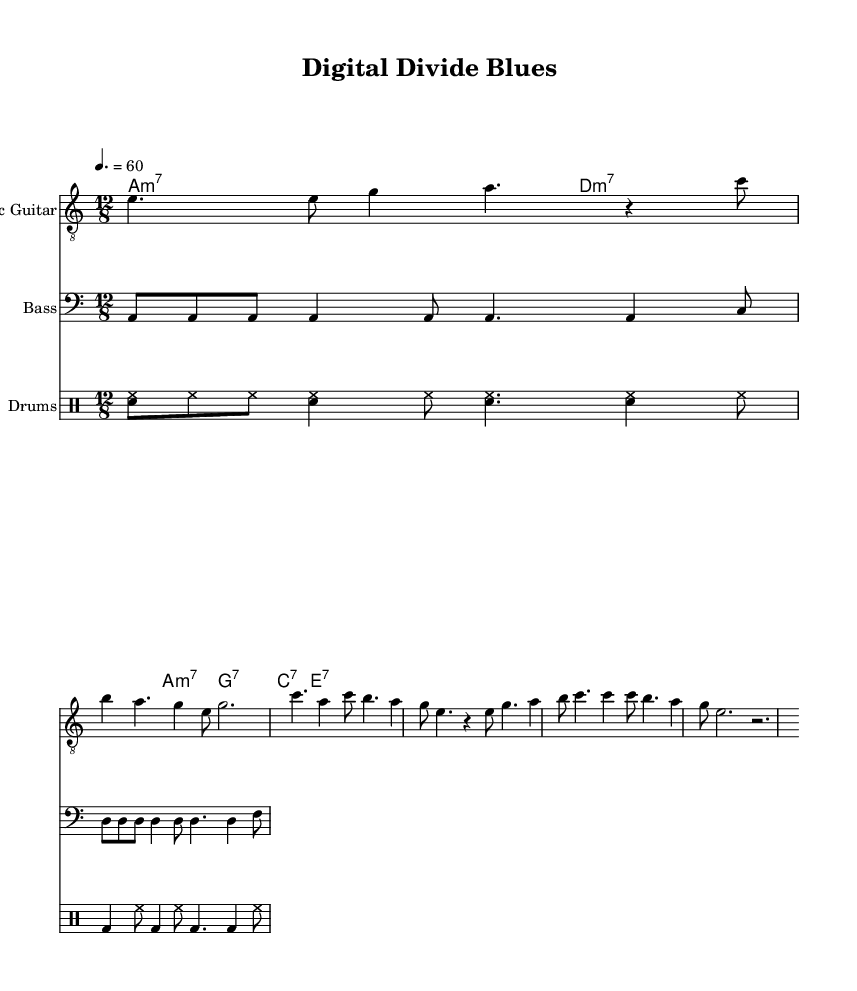What is the key signature of this music? The key signature is A minor, which has no sharps or flats.
Answer: A minor What is the time signature of this piece? The time signature is written in the top left of the sheet music, showing 12/8, indicating a compound meter.
Answer: 12/8 What is the tempo marking given in the score? The tempo is indicated as 4 beats per measure equaling 60 beats per minute, specifying the pace of the music.
Answer: 60 What is the primary chord progression in the chorus? The chorus uses the chords A minor 7, D minor 7, G dominant 7, C dominant 7, and E dominant 7, which can be found in the harmony section.
Answer: A minor 7, D minor 7, G dominant 7, C dominant 7, E dominant 7 Explain the instrument playing the drum pattern. The drum pattern is specifically written for a drum kit, indicated in the drum staff section. The notation includes elements like hi-hat and bass drum.
Answer: Drum kit What distinguishes the verse from the chorus in the music structure? The verse's melody has a different rhythmic structure compared to the chorus, and the chorus features repeated notes and a simpler rhythmic flow, showcasing the emotional height of the piece.
Answer: Rhythmic structure How does the electric guitar contribute to the overall mood of the piece? The electric guitar uses a combination of ascending and descending melodic phrases that enhance the expressiveness essential to Electric Blues. These guitar phrases contribute to the gritty urban flavor of the song.
Answer: Enhances expressiveness 